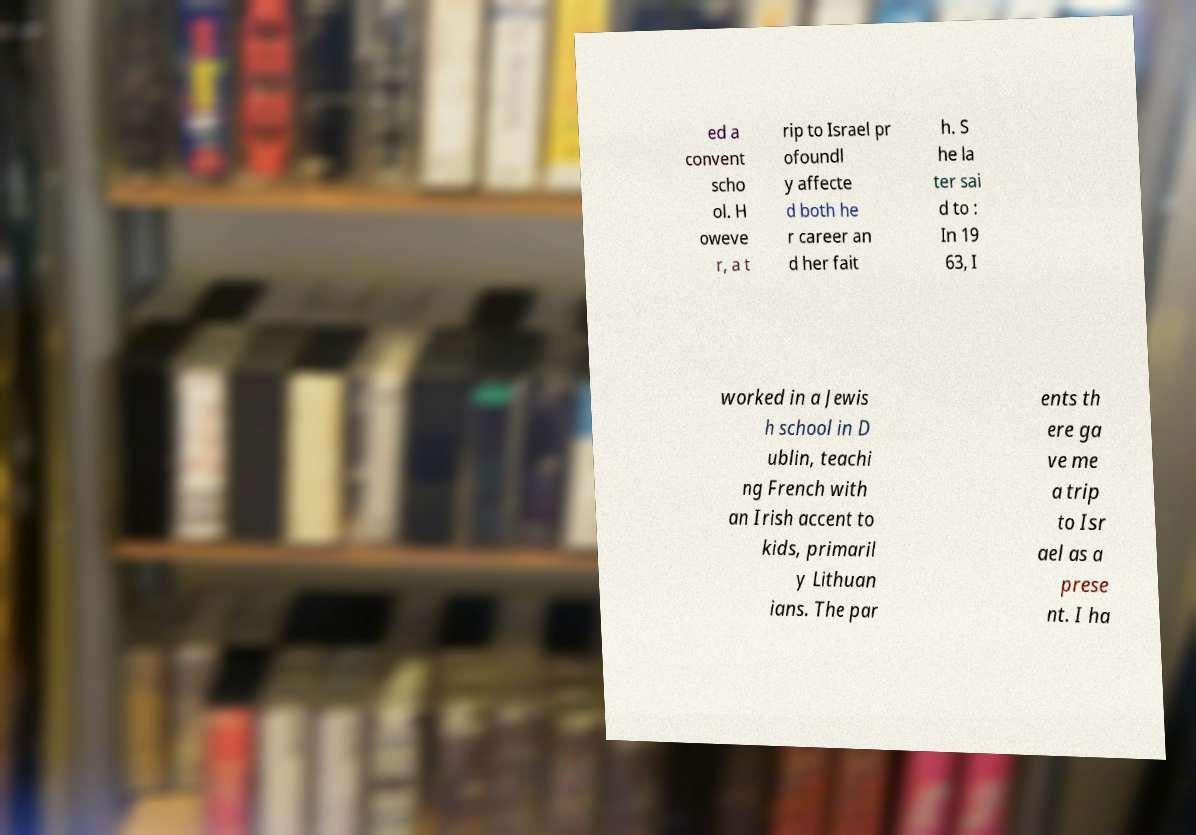Can you read and provide the text displayed in the image?This photo seems to have some interesting text. Can you extract and type it out for me? ed a convent scho ol. H oweve r, a t rip to Israel pr ofoundl y affecte d both he r career an d her fait h. S he la ter sai d to : In 19 63, I worked in a Jewis h school in D ublin, teachi ng French with an Irish accent to kids, primaril y Lithuan ians. The par ents th ere ga ve me a trip to Isr ael as a prese nt. I ha 